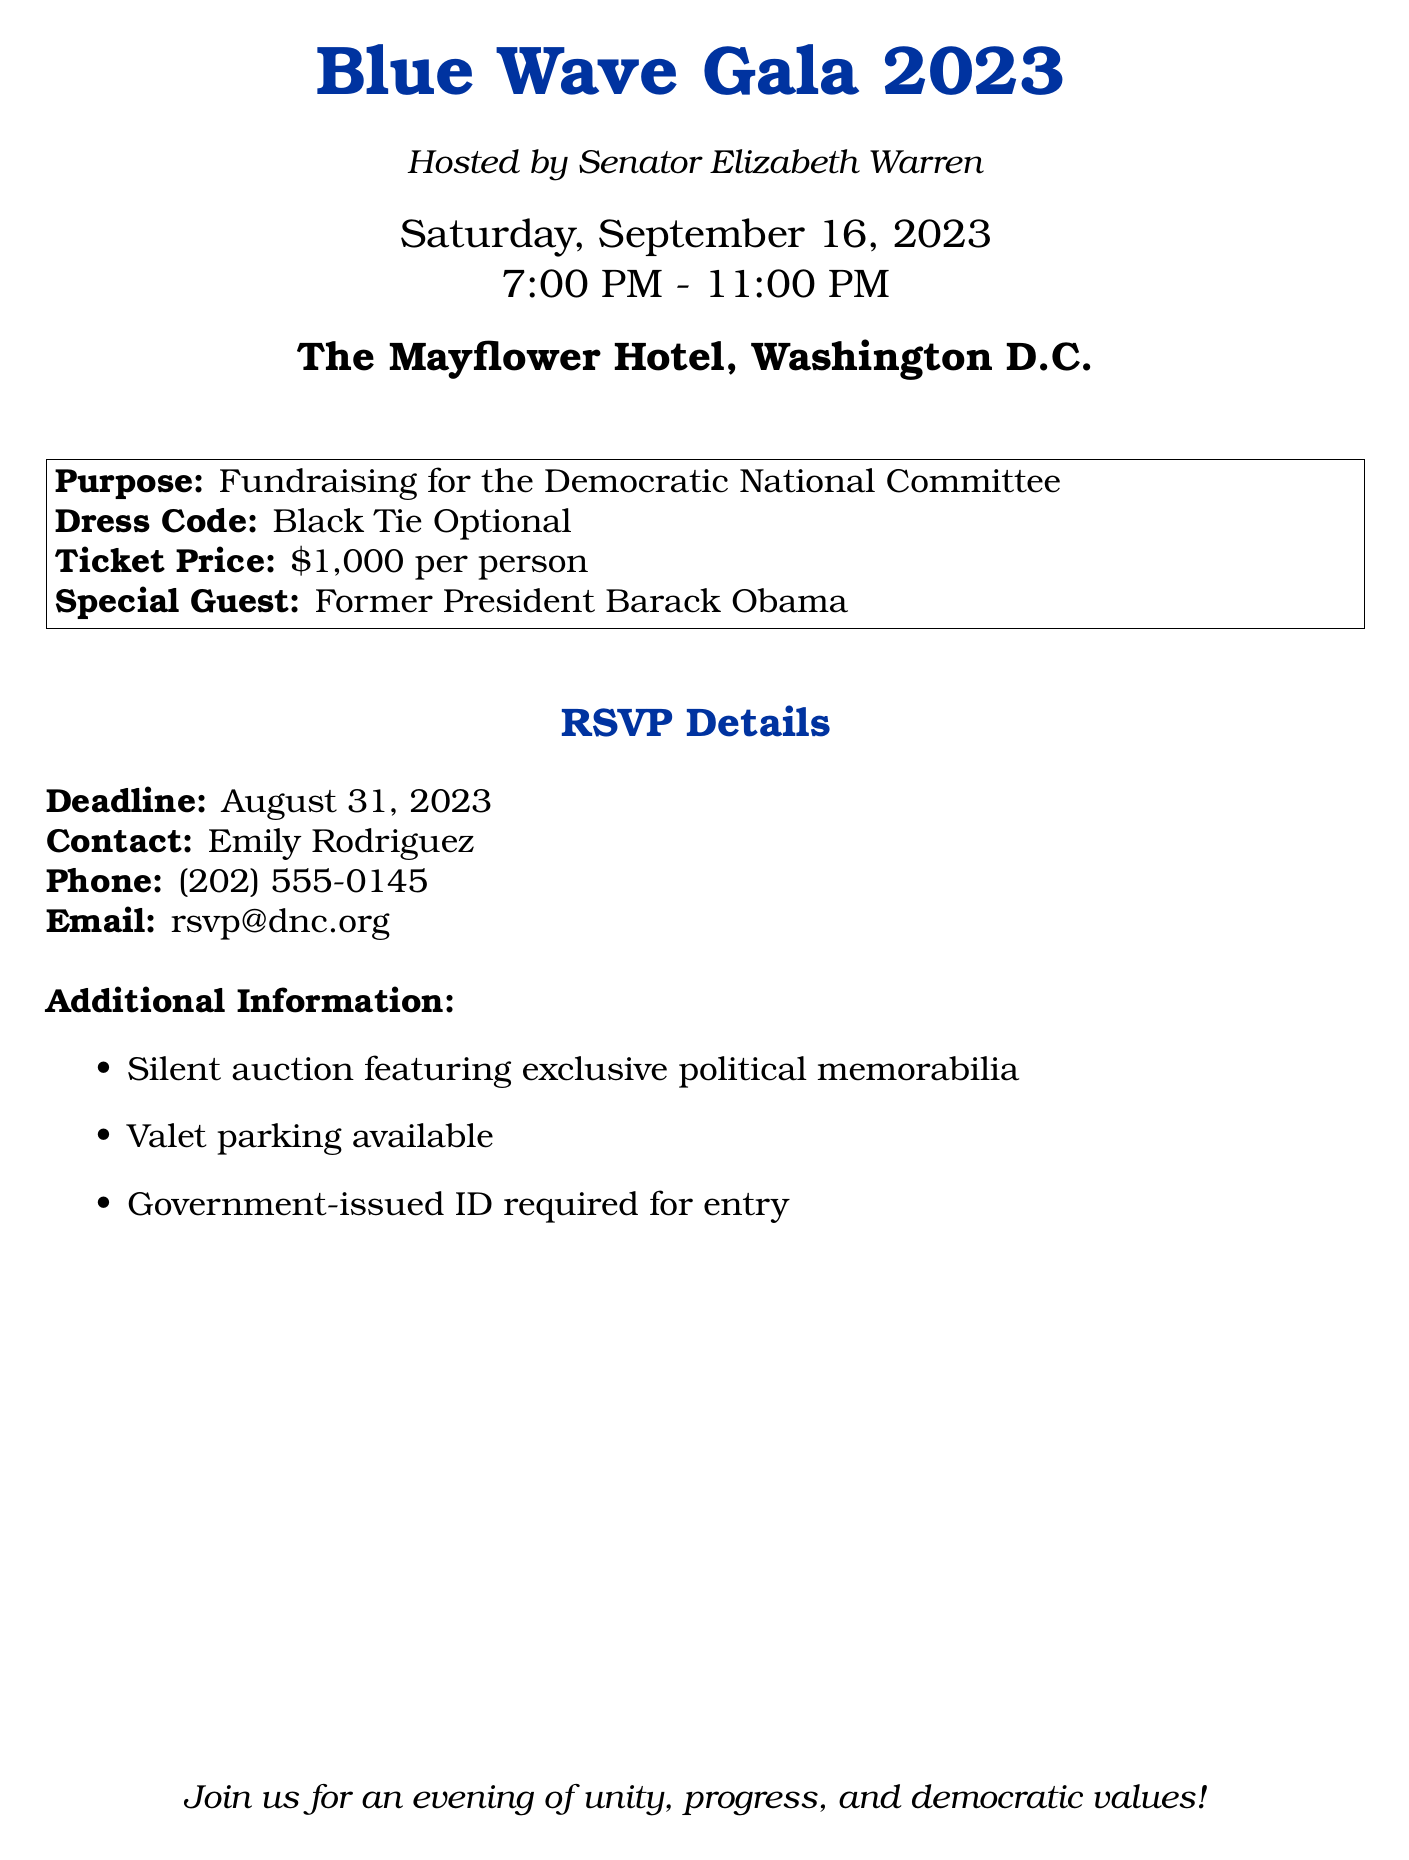What is the event's title? The title of the event is explicitly stated at the top of the document as "Blue Wave Gala 2023."
Answer: Blue Wave Gala 2023 Who is hosting the event? The host of the event is mentioned right below the title as "Senator Elizabeth Warren."
Answer: Senator Elizabeth Warren What is the date of the gala? The date is clearly indicated in the document as "Saturday, September 16, 2023."
Answer: Saturday, September 16, 2023 What is the ticket price? The document specifies the ticket price as "$1,000 per person."
Answer: $1,000 per person Who is the special guest? The special guest is highlighted in the text, and it states "Former President Barack Obama."
Answer: Former President Barack Obama What is the dress code for the gala? The dress code is clearly listed in the document as "Black Tie Optional."
Answer: Black Tie Optional When is the RSVP deadline? The RSVP deadline is stated in the document as "August 31, 2023."
Answer: August 31, 2023 What additional feature is mentioned for the event? The document lists a feature of a "Silent auction featuring exclusive political memorabilia."
Answer: Silent auction featuring exclusive political memorabilia What type of parking is available? It is mentioned in the additional information section that "Valet parking available."
Answer: Valet parking available 